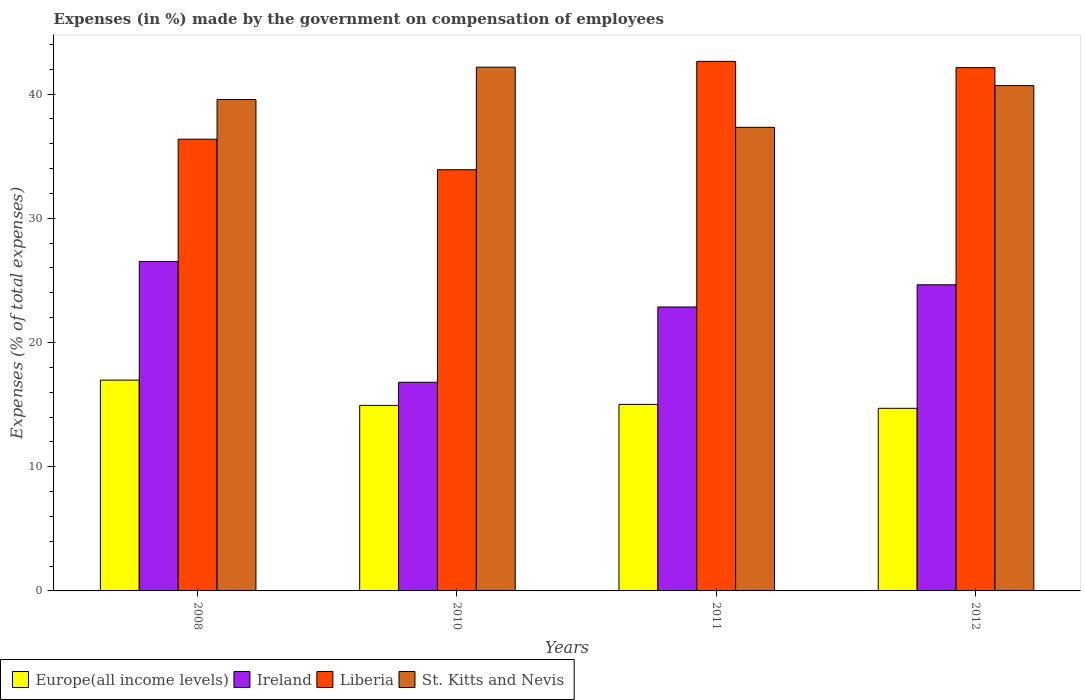How many different coloured bars are there?
Ensure brevity in your answer.  4. Are the number of bars per tick equal to the number of legend labels?
Offer a very short reply. Yes. How many bars are there on the 4th tick from the right?
Your answer should be very brief. 4. What is the label of the 2nd group of bars from the left?
Offer a terse response. 2010. In how many cases, is the number of bars for a given year not equal to the number of legend labels?
Give a very brief answer. 0. What is the percentage of expenses made by the government on compensation of employees in Ireland in 2011?
Your answer should be compact. 22.86. Across all years, what is the maximum percentage of expenses made by the government on compensation of employees in Europe(all income levels)?
Make the answer very short. 16.97. Across all years, what is the minimum percentage of expenses made by the government on compensation of employees in Europe(all income levels)?
Your answer should be very brief. 14.7. What is the total percentage of expenses made by the government on compensation of employees in Liberia in the graph?
Your answer should be compact. 155.03. What is the difference between the percentage of expenses made by the government on compensation of employees in Europe(all income levels) in 2008 and that in 2012?
Your answer should be very brief. 2.27. What is the difference between the percentage of expenses made by the government on compensation of employees in St. Kitts and Nevis in 2008 and the percentage of expenses made by the government on compensation of employees in Ireland in 2010?
Your response must be concise. 22.76. What is the average percentage of expenses made by the government on compensation of employees in Ireland per year?
Ensure brevity in your answer.  22.7. In the year 2011, what is the difference between the percentage of expenses made by the government on compensation of employees in St. Kitts and Nevis and percentage of expenses made by the government on compensation of employees in Europe(all income levels)?
Provide a short and direct response. 22.3. What is the ratio of the percentage of expenses made by the government on compensation of employees in St. Kitts and Nevis in 2008 to that in 2012?
Offer a very short reply. 0.97. Is the percentage of expenses made by the government on compensation of employees in St. Kitts and Nevis in 2008 less than that in 2011?
Provide a succinct answer. No. Is the difference between the percentage of expenses made by the government on compensation of employees in St. Kitts and Nevis in 2008 and 2010 greater than the difference between the percentage of expenses made by the government on compensation of employees in Europe(all income levels) in 2008 and 2010?
Offer a terse response. No. What is the difference between the highest and the second highest percentage of expenses made by the government on compensation of employees in Ireland?
Provide a short and direct response. 1.88. What is the difference between the highest and the lowest percentage of expenses made by the government on compensation of employees in St. Kitts and Nevis?
Give a very brief answer. 4.84. In how many years, is the percentage of expenses made by the government on compensation of employees in St. Kitts and Nevis greater than the average percentage of expenses made by the government on compensation of employees in St. Kitts and Nevis taken over all years?
Offer a very short reply. 2. Is it the case that in every year, the sum of the percentage of expenses made by the government on compensation of employees in St. Kitts and Nevis and percentage of expenses made by the government on compensation of employees in Europe(all income levels) is greater than the sum of percentage of expenses made by the government on compensation of employees in Ireland and percentage of expenses made by the government on compensation of employees in Liberia?
Offer a very short reply. Yes. What does the 2nd bar from the left in 2008 represents?
Offer a very short reply. Ireland. What does the 1st bar from the right in 2008 represents?
Offer a very short reply. St. Kitts and Nevis. Is it the case that in every year, the sum of the percentage of expenses made by the government on compensation of employees in Europe(all income levels) and percentage of expenses made by the government on compensation of employees in Ireland is greater than the percentage of expenses made by the government on compensation of employees in St. Kitts and Nevis?
Your answer should be very brief. No. Are all the bars in the graph horizontal?
Give a very brief answer. No. How many years are there in the graph?
Ensure brevity in your answer.  4. What is the difference between two consecutive major ticks on the Y-axis?
Your response must be concise. 10. Does the graph contain any zero values?
Provide a succinct answer. No. Where does the legend appear in the graph?
Offer a terse response. Bottom left. How are the legend labels stacked?
Make the answer very short. Horizontal. What is the title of the graph?
Give a very brief answer. Expenses (in %) made by the government on compensation of employees. What is the label or title of the X-axis?
Offer a terse response. Years. What is the label or title of the Y-axis?
Make the answer very short. Expenses (% of total expenses). What is the Expenses (% of total expenses) of Europe(all income levels) in 2008?
Give a very brief answer. 16.97. What is the Expenses (% of total expenses) of Ireland in 2008?
Keep it short and to the point. 26.52. What is the Expenses (% of total expenses) of Liberia in 2008?
Your answer should be compact. 36.36. What is the Expenses (% of total expenses) in St. Kitts and Nevis in 2008?
Give a very brief answer. 39.56. What is the Expenses (% of total expenses) in Europe(all income levels) in 2010?
Give a very brief answer. 14.94. What is the Expenses (% of total expenses) in Ireland in 2010?
Make the answer very short. 16.8. What is the Expenses (% of total expenses) of Liberia in 2010?
Ensure brevity in your answer.  33.91. What is the Expenses (% of total expenses) in St. Kitts and Nevis in 2010?
Provide a succinct answer. 42.16. What is the Expenses (% of total expenses) in Europe(all income levels) in 2011?
Offer a terse response. 15.02. What is the Expenses (% of total expenses) in Ireland in 2011?
Keep it short and to the point. 22.86. What is the Expenses (% of total expenses) of Liberia in 2011?
Make the answer very short. 42.63. What is the Expenses (% of total expenses) in St. Kitts and Nevis in 2011?
Your answer should be very brief. 37.32. What is the Expenses (% of total expenses) of Europe(all income levels) in 2012?
Offer a terse response. 14.7. What is the Expenses (% of total expenses) in Ireland in 2012?
Your answer should be very brief. 24.64. What is the Expenses (% of total expenses) in Liberia in 2012?
Your answer should be compact. 42.12. What is the Expenses (% of total expenses) in St. Kitts and Nevis in 2012?
Provide a short and direct response. 40.68. Across all years, what is the maximum Expenses (% of total expenses) of Europe(all income levels)?
Keep it short and to the point. 16.97. Across all years, what is the maximum Expenses (% of total expenses) in Ireland?
Make the answer very short. 26.52. Across all years, what is the maximum Expenses (% of total expenses) in Liberia?
Offer a very short reply. 42.63. Across all years, what is the maximum Expenses (% of total expenses) in St. Kitts and Nevis?
Your answer should be very brief. 42.16. Across all years, what is the minimum Expenses (% of total expenses) in Europe(all income levels)?
Provide a short and direct response. 14.7. Across all years, what is the minimum Expenses (% of total expenses) of Ireland?
Make the answer very short. 16.8. Across all years, what is the minimum Expenses (% of total expenses) of Liberia?
Your answer should be compact. 33.91. Across all years, what is the minimum Expenses (% of total expenses) of St. Kitts and Nevis?
Offer a terse response. 37.32. What is the total Expenses (% of total expenses) of Europe(all income levels) in the graph?
Provide a short and direct response. 61.63. What is the total Expenses (% of total expenses) of Ireland in the graph?
Offer a terse response. 90.82. What is the total Expenses (% of total expenses) of Liberia in the graph?
Your answer should be compact. 155.03. What is the total Expenses (% of total expenses) in St. Kitts and Nevis in the graph?
Your answer should be compact. 159.71. What is the difference between the Expenses (% of total expenses) of Europe(all income levels) in 2008 and that in 2010?
Ensure brevity in your answer.  2.04. What is the difference between the Expenses (% of total expenses) in Ireland in 2008 and that in 2010?
Give a very brief answer. 9.72. What is the difference between the Expenses (% of total expenses) in Liberia in 2008 and that in 2010?
Give a very brief answer. 2.46. What is the difference between the Expenses (% of total expenses) of St. Kitts and Nevis in 2008 and that in 2010?
Ensure brevity in your answer.  -2.61. What is the difference between the Expenses (% of total expenses) of Europe(all income levels) in 2008 and that in 2011?
Provide a succinct answer. 1.96. What is the difference between the Expenses (% of total expenses) of Ireland in 2008 and that in 2011?
Ensure brevity in your answer.  3.67. What is the difference between the Expenses (% of total expenses) of Liberia in 2008 and that in 2011?
Ensure brevity in your answer.  -6.27. What is the difference between the Expenses (% of total expenses) in St. Kitts and Nevis in 2008 and that in 2011?
Your answer should be very brief. 2.24. What is the difference between the Expenses (% of total expenses) in Europe(all income levels) in 2008 and that in 2012?
Your answer should be compact. 2.27. What is the difference between the Expenses (% of total expenses) of Ireland in 2008 and that in 2012?
Offer a terse response. 1.88. What is the difference between the Expenses (% of total expenses) of Liberia in 2008 and that in 2012?
Give a very brief answer. -5.76. What is the difference between the Expenses (% of total expenses) in St. Kitts and Nevis in 2008 and that in 2012?
Provide a short and direct response. -1.12. What is the difference between the Expenses (% of total expenses) in Europe(all income levels) in 2010 and that in 2011?
Provide a succinct answer. -0.08. What is the difference between the Expenses (% of total expenses) of Ireland in 2010 and that in 2011?
Provide a succinct answer. -6.06. What is the difference between the Expenses (% of total expenses) in Liberia in 2010 and that in 2011?
Offer a terse response. -8.72. What is the difference between the Expenses (% of total expenses) of St. Kitts and Nevis in 2010 and that in 2011?
Keep it short and to the point. 4.84. What is the difference between the Expenses (% of total expenses) of Europe(all income levels) in 2010 and that in 2012?
Your answer should be very brief. 0.23. What is the difference between the Expenses (% of total expenses) in Ireland in 2010 and that in 2012?
Offer a very short reply. -7.85. What is the difference between the Expenses (% of total expenses) of Liberia in 2010 and that in 2012?
Offer a very short reply. -8.22. What is the difference between the Expenses (% of total expenses) of St. Kitts and Nevis in 2010 and that in 2012?
Your answer should be compact. 1.48. What is the difference between the Expenses (% of total expenses) in Europe(all income levels) in 2011 and that in 2012?
Your answer should be very brief. 0.32. What is the difference between the Expenses (% of total expenses) of Ireland in 2011 and that in 2012?
Your response must be concise. -1.79. What is the difference between the Expenses (% of total expenses) of Liberia in 2011 and that in 2012?
Give a very brief answer. 0.51. What is the difference between the Expenses (% of total expenses) in St. Kitts and Nevis in 2011 and that in 2012?
Offer a terse response. -3.36. What is the difference between the Expenses (% of total expenses) of Europe(all income levels) in 2008 and the Expenses (% of total expenses) of Ireland in 2010?
Provide a short and direct response. 0.18. What is the difference between the Expenses (% of total expenses) of Europe(all income levels) in 2008 and the Expenses (% of total expenses) of Liberia in 2010?
Provide a succinct answer. -16.94. What is the difference between the Expenses (% of total expenses) in Europe(all income levels) in 2008 and the Expenses (% of total expenses) in St. Kitts and Nevis in 2010?
Offer a very short reply. -25.19. What is the difference between the Expenses (% of total expenses) of Ireland in 2008 and the Expenses (% of total expenses) of Liberia in 2010?
Provide a succinct answer. -7.39. What is the difference between the Expenses (% of total expenses) of Ireland in 2008 and the Expenses (% of total expenses) of St. Kitts and Nevis in 2010?
Your answer should be very brief. -15.64. What is the difference between the Expenses (% of total expenses) in Liberia in 2008 and the Expenses (% of total expenses) in St. Kitts and Nevis in 2010?
Offer a very short reply. -5.8. What is the difference between the Expenses (% of total expenses) in Europe(all income levels) in 2008 and the Expenses (% of total expenses) in Ireland in 2011?
Ensure brevity in your answer.  -5.88. What is the difference between the Expenses (% of total expenses) of Europe(all income levels) in 2008 and the Expenses (% of total expenses) of Liberia in 2011?
Make the answer very short. -25.66. What is the difference between the Expenses (% of total expenses) in Europe(all income levels) in 2008 and the Expenses (% of total expenses) in St. Kitts and Nevis in 2011?
Make the answer very short. -20.35. What is the difference between the Expenses (% of total expenses) of Ireland in 2008 and the Expenses (% of total expenses) of Liberia in 2011?
Keep it short and to the point. -16.11. What is the difference between the Expenses (% of total expenses) of Ireland in 2008 and the Expenses (% of total expenses) of St. Kitts and Nevis in 2011?
Provide a succinct answer. -10.8. What is the difference between the Expenses (% of total expenses) in Liberia in 2008 and the Expenses (% of total expenses) in St. Kitts and Nevis in 2011?
Your response must be concise. -0.95. What is the difference between the Expenses (% of total expenses) of Europe(all income levels) in 2008 and the Expenses (% of total expenses) of Ireland in 2012?
Your answer should be compact. -7.67. What is the difference between the Expenses (% of total expenses) of Europe(all income levels) in 2008 and the Expenses (% of total expenses) of Liberia in 2012?
Provide a short and direct response. -25.15. What is the difference between the Expenses (% of total expenses) of Europe(all income levels) in 2008 and the Expenses (% of total expenses) of St. Kitts and Nevis in 2012?
Offer a very short reply. -23.71. What is the difference between the Expenses (% of total expenses) in Ireland in 2008 and the Expenses (% of total expenses) in Liberia in 2012?
Provide a short and direct response. -15.6. What is the difference between the Expenses (% of total expenses) of Ireland in 2008 and the Expenses (% of total expenses) of St. Kitts and Nevis in 2012?
Make the answer very short. -14.16. What is the difference between the Expenses (% of total expenses) in Liberia in 2008 and the Expenses (% of total expenses) in St. Kitts and Nevis in 2012?
Provide a succinct answer. -4.31. What is the difference between the Expenses (% of total expenses) in Europe(all income levels) in 2010 and the Expenses (% of total expenses) in Ireland in 2011?
Offer a very short reply. -7.92. What is the difference between the Expenses (% of total expenses) in Europe(all income levels) in 2010 and the Expenses (% of total expenses) in Liberia in 2011?
Give a very brief answer. -27.69. What is the difference between the Expenses (% of total expenses) of Europe(all income levels) in 2010 and the Expenses (% of total expenses) of St. Kitts and Nevis in 2011?
Your answer should be compact. -22.38. What is the difference between the Expenses (% of total expenses) of Ireland in 2010 and the Expenses (% of total expenses) of Liberia in 2011?
Your response must be concise. -25.83. What is the difference between the Expenses (% of total expenses) of Ireland in 2010 and the Expenses (% of total expenses) of St. Kitts and Nevis in 2011?
Make the answer very short. -20.52. What is the difference between the Expenses (% of total expenses) of Liberia in 2010 and the Expenses (% of total expenses) of St. Kitts and Nevis in 2011?
Provide a short and direct response. -3.41. What is the difference between the Expenses (% of total expenses) of Europe(all income levels) in 2010 and the Expenses (% of total expenses) of Ireland in 2012?
Give a very brief answer. -9.71. What is the difference between the Expenses (% of total expenses) of Europe(all income levels) in 2010 and the Expenses (% of total expenses) of Liberia in 2012?
Ensure brevity in your answer.  -27.19. What is the difference between the Expenses (% of total expenses) of Europe(all income levels) in 2010 and the Expenses (% of total expenses) of St. Kitts and Nevis in 2012?
Your response must be concise. -25.74. What is the difference between the Expenses (% of total expenses) in Ireland in 2010 and the Expenses (% of total expenses) in Liberia in 2012?
Provide a short and direct response. -25.33. What is the difference between the Expenses (% of total expenses) in Ireland in 2010 and the Expenses (% of total expenses) in St. Kitts and Nevis in 2012?
Your response must be concise. -23.88. What is the difference between the Expenses (% of total expenses) in Liberia in 2010 and the Expenses (% of total expenses) in St. Kitts and Nevis in 2012?
Provide a succinct answer. -6.77. What is the difference between the Expenses (% of total expenses) in Europe(all income levels) in 2011 and the Expenses (% of total expenses) in Ireland in 2012?
Make the answer very short. -9.63. What is the difference between the Expenses (% of total expenses) in Europe(all income levels) in 2011 and the Expenses (% of total expenses) in Liberia in 2012?
Provide a short and direct response. -27.11. What is the difference between the Expenses (% of total expenses) of Europe(all income levels) in 2011 and the Expenses (% of total expenses) of St. Kitts and Nevis in 2012?
Your answer should be very brief. -25.66. What is the difference between the Expenses (% of total expenses) of Ireland in 2011 and the Expenses (% of total expenses) of Liberia in 2012?
Offer a very short reply. -19.27. What is the difference between the Expenses (% of total expenses) of Ireland in 2011 and the Expenses (% of total expenses) of St. Kitts and Nevis in 2012?
Make the answer very short. -17.82. What is the difference between the Expenses (% of total expenses) of Liberia in 2011 and the Expenses (% of total expenses) of St. Kitts and Nevis in 2012?
Ensure brevity in your answer.  1.95. What is the average Expenses (% of total expenses) of Europe(all income levels) per year?
Offer a very short reply. 15.41. What is the average Expenses (% of total expenses) in Ireland per year?
Your response must be concise. 22.7. What is the average Expenses (% of total expenses) of Liberia per year?
Your response must be concise. 38.76. What is the average Expenses (% of total expenses) in St. Kitts and Nevis per year?
Keep it short and to the point. 39.93. In the year 2008, what is the difference between the Expenses (% of total expenses) of Europe(all income levels) and Expenses (% of total expenses) of Ireland?
Make the answer very short. -9.55. In the year 2008, what is the difference between the Expenses (% of total expenses) in Europe(all income levels) and Expenses (% of total expenses) in Liberia?
Ensure brevity in your answer.  -19.39. In the year 2008, what is the difference between the Expenses (% of total expenses) of Europe(all income levels) and Expenses (% of total expenses) of St. Kitts and Nevis?
Give a very brief answer. -22.58. In the year 2008, what is the difference between the Expenses (% of total expenses) of Ireland and Expenses (% of total expenses) of Liberia?
Provide a short and direct response. -9.84. In the year 2008, what is the difference between the Expenses (% of total expenses) in Ireland and Expenses (% of total expenses) in St. Kitts and Nevis?
Keep it short and to the point. -13.04. In the year 2008, what is the difference between the Expenses (% of total expenses) of Liberia and Expenses (% of total expenses) of St. Kitts and Nevis?
Make the answer very short. -3.19. In the year 2010, what is the difference between the Expenses (% of total expenses) in Europe(all income levels) and Expenses (% of total expenses) in Ireland?
Your response must be concise. -1.86. In the year 2010, what is the difference between the Expenses (% of total expenses) of Europe(all income levels) and Expenses (% of total expenses) of Liberia?
Provide a short and direct response. -18.97. In the year 2010, what is the difference between the Expenses (% of total expenses) of Europe(all income levels) and Expenses (% of total expenses) of St. Kitts and Nevis?
Your response must be concise. -27.23. In the year 2010, what is the difference between the Expenses (% of total expenses) in Ireland and Expenses (% of total expenses) in Liberia?
Make the answer very short. -17.11. In the year 2010, what is the difference between the Expenses (% of total expenses) in Ireland and Expenses (% of total expenses) in St. Kitts and Nevis?
Offer a very short reply. -25.37. In the year 2010, what is the difference between the Expenses (% of total expenses) of Liberia and Expenses (% of total expenses) of St. Kitts and Nevis?
Offer a terse response. -8.25. In the year 2011, what is the difference between the Expenses (% of total expenses) in Europe(all income levels) and Expenses (% of total expenses) in Ireland?
Your response must be concise. -7.84. In the year 2011, what is the difference between the Expenses (% of total expenses) of Europe(all income levels) and Expenses (% of total expenses) of Liberia?
Your answer should be very brief. -27.61. In the year 2011, what is the difference between the Expenses (% of total expenses) in Europe(all income levels) and Expenses (% of total expenses) in St. Kitts and Nevis?
Give a very brief answer. -22.3. In the year 2011, what is the difference between the Expenses (% of total expenses) in Ireland and Expenses (% of total expenses) in Liberia?
Ensure brevity in your answer.  -19.77. In the year 2011, what is the difference between the Expenses (% of total expenses) of Ireland and Expenses (% of total expenses) of St. Kitts and Nevis?
Keep it short and to the point. -14.46. In the year 2011, what is the difference between the Expenses (% of total expenses) of Liberia and Expenses (% of total expenses) of St. Kitts and Nevis?
Offer a very short reply. 5.31. In the year 2012, what is the difference between the Expenses (% of total expenses) of Europe(all income levels) and Expenses (% of total expenses) of Ireland?
Offer a very short reply. -9.94. In the year 2012, what is the difference between the Expenses (% of total expenses) of Europe(all income levels) and Expenses (% of total expenses) of Liberia?
Your answer should be compact. -27.42. In the year 2012, what is the difference between the Expenses (% of total expenses) of Europe(all income levels) and Expenses (% of total expenses) of St. Kitts and Nevis?
Give a very brief answer. -25.98. In the year 2012, what is the difference between the Expenses (% of total expenses) of Ireland and Expenses (% of total expenses) of Liberia?
Offer a terse response. -17.48. In the year 2012, what is the difference between the Expenses (% of total expenses) of Ireland and Expenses (% of total expenses) of St. Kitts and Nevis?
Offer a terse response. -16.03. In the year 2012, what is the difference between the Expenses (% of total expenses) of Liberia and Expenses (% of total expenses) of St. Kitts and Nevis?
Provide a short and direct response. 1.45. What is the ratio of the Expenses (% of total expenses) of Europe(all income levels) in 2008 to that in 2010?
Offer a very short reply. 1.14. What is the ratio of the Expenses (% of total expenses) of Ireland in 2008 to that in 2010?
Your answer should be very brief. 1.58. What is the ratio of the Expenses (% of total expenses) in Liberia in 2008 to that in 2010?
Your answer should be very brief. 1.07. What is the ratio of the Expenses (% of total expenses) of St. Kitts and Nevis in 2008 to that in 2010?
Offer a terse response. 0.94. What is the ratio of the Expenses (% of total expenses) of Europe(all income levels) in 2008 to that in 2011?
Your answer should be compact. 1.13. What is the ratio of the Expenses (% of total expenses) in Ireland in 2008 to that in 2011?
Offer a very short reply. 1.16. What is the ratio of the Expenses (% of total expenses) in Liberia in 2008 to that in 2011?
Keep it short and to the point. 0.85. What is the ratio of the Expenses (% of total expenses) of St. Kitts and Nevis in 2008 to that in 2011?
Give a very brief answer. 1.06. What is the ratio of the Expenses (% of total expenses) in Europe(all income levels) in 2008 to that in 2012?
Give a very brief answer. 1.15. What is the ratio of the Expenses (% of total expenses) in Ireland in 2008 to that in 2012?
Make the answer very short. 1.08. What is the ratio of the Expenses (% of total expenses) in Liberia in 2008 to that in 2012?
Make the answer very short. 0.86. What is the ratio of the Expenses (% of total expenses) of St. Kitts and Nevis in 2008 to that in 2012?
Give a very brief answer. 0.97. What is the ratio of the Expenses (% of total expenses) in Europe(all income levels) in 2010 to that in 2011?
Provide a short and direct response. 0.99. What is the ratio of the Expenses (% of total expenses) of Ireland in 2010 to that in 2011?
Make the answer very short. 0.73. What is the ratio of the Expenses (% of total expenses) of Liberia in 2010 to that in 2011?
Your answer should be compact. 0.8. What is the ratio of the Expenses (% of total expenses) of St. Kitts and Nevis in 2010 to that in 2011?
Your answer should be very brief. 1.13. What is the ratio of the Expenses (% of total expenses) in Europe(all income levels) in 2010 to that in 2012?
Keep it short and to the point. 1.02. What is the ratio of the Expenses (% of total expenses) of Ireland in 2010 to that in 2012?
Provide a short and direct response. 0.68. What is the ratio of the Expenses (% of total expenses) of Liberia in 2010 to that in 2012?
Give a very brief answer. 0.81. What is the ratio of the Expenses (% of total expenses) of St. Kitts and Nevis in 2010 to that in 2012?
Keep it short and to the point. 1.04. What is the ratio of the Expenses (% of total expenses) in Europe(all income levels) in 2011 to that in 2012?
Offer a very short reply. 1.02. What is the ratio of the Expenses (% of total expenses) of Ireland in 2011 to that in 2012?
Ensure brevity in your answer.  0.93. What is the ratio of the Expenses (% of total expenses) in Liberia in 2011 to that in 2012?
Keep it short and to the point. 1.01. What is the ratio of the Expenses (% of total expenses) of St. Kitts and Nevis in 2011 to that in 2012?
Ensure brevity in your answer.  0.92. What is the difference between the highest and the second highest Expenses (% of total expenses) of Europe(all income levels)?
Provide a short and direct response. 1.96. What is the difference between the highest and the second highest Expenses (% of total expenses) in Ireland?
Give a very brief answer. 1.88. What is the difference between the highest and the second highest Expenses (% of total expenses) in Liberia?
Your response must be concise. 0.51. What is the difference between the highest and the second highest Expenses (% of total expenses) in St. Kitts and Nevis?
Offer a very short reply. 1.48. What is the difference between the highest and the lowest Expenses (% of total expenses) in Europe(all income levels)?
Give a very brief answer. 2.27. What is the difference between the highest and the lowest Expenses (% of total expenses) of Ireland?
Ensure brevity in your answer.  9.72. What is the difference between the highest and the lowest Expenses (% of total expenses) in Liberia?
Offer a terse response. 8.72. What is the difference between the highest and the lowest Expenses (% of total expenses) of St. Kitts and Nevis?
Keep it short and to the point. 4.84. 